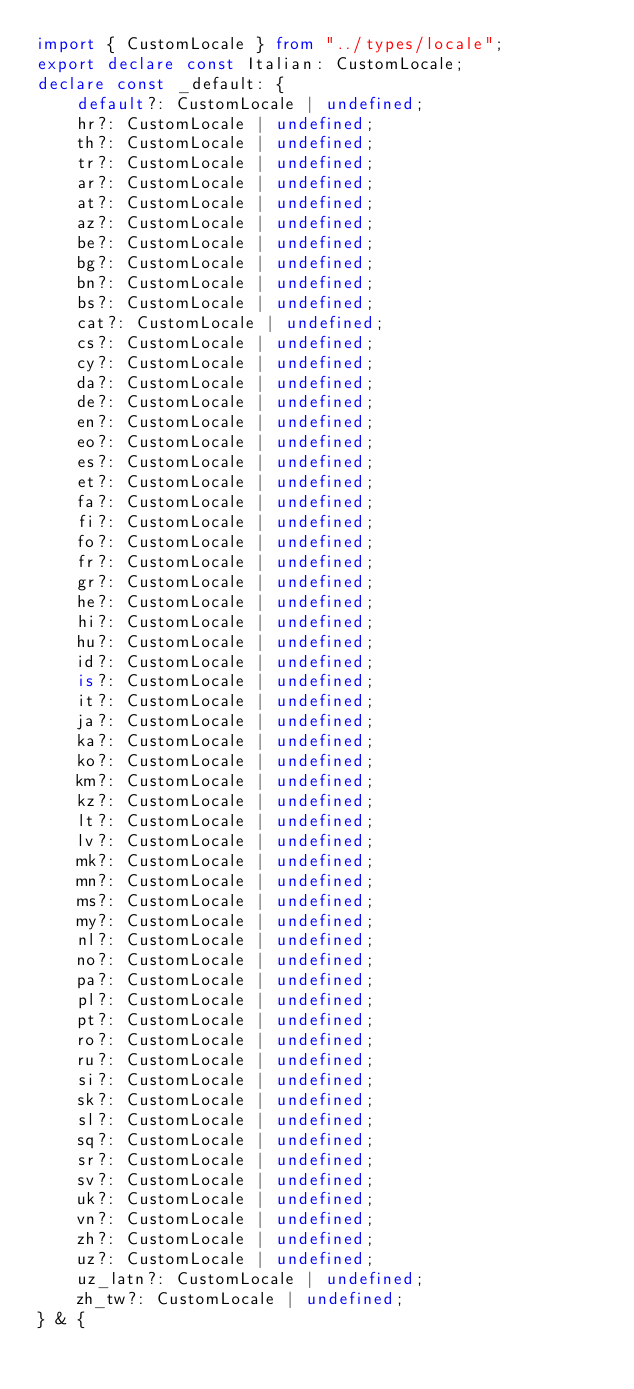Convert code to text. <code><loc_0><loc_0><loc_500><loc_500><_TypeScript_>import { CustomLocale } from "../types/locale";
export declare const Italian: CustomLocale;
declare const _default: {
    default?: CustomLocale | undefined;
    hr?: CustomLocale | undefined;
    th?: CustomLocale | undefined;
    tr?: CustomLocale | undefined;
    ar?: CustomLocale | undefined;
    at?: CustomLocale | undefined;
    az?: CustomLocale | undefined;
    be?: CustomLocale | undefined;
    bg?: CustomLocale | undefined;
    bn?: CustomLocale | undefined;
    bs?: CustomLocale | undefined;
    cat?: CustomLocale | undefined;
    cs?: CustomLocale | undefined;
    cy?: CustomLocale | undefined;
    da?: CustomLocale | undefined;
    de?: CustomLocale | undefined;
    en?: CustomLocale | undefined;
    eo?: CustomLocale | undefined;
    es?: CustomLocale | undefined;
    et?: CustomLocale | undefined;
    fa?: CustomLocale | undefined;
    fi?: CustomLocale | undefined;
    fo?: CustomLocale | undefined;
    fr?: CustomLocale | undefined;
    gr?: CustomLocale | undefined;
    he?: CustomLocale | undefined;
    hi?: CustomLocale | undefined;
    hu?: CustomLocale | undefined;
    id?: CustomLocale | undefined;
    is?: CustomLocale | undefined;
    it?: CustomLocale | undefined;
    ja?: CustomLocale | undefined;
    ka?: CustomLocale | undefined;
    ko?: CustomLocale | undefined;
    km?: CustomLocale | undefined;
    kz?: CustomLocale | undefined;
    lt?: CustomLocale | undefined;
    lv?: CustomLocale | undefined;
    mk?: CustomLocale | undefined;
    mn?: CustomLocale | undefined;
    ms?: CustomLocale | undefined;
    my?: CustomLocale | undefined;
    nl?: CustomLocale | undefined;
    no?: CustomLocale | undefined;
    pa?: CustomLocale | undefined;
    pl?: CustomLocale | undefined;
    pt?: CustomLocale | undefined;
    ro?: CustomLocale | undefined;
    ru?: CustomLocale | undefined;
    si?: CustomLocale | undefined;
    sk?: CustomLocale | undefined;
    sl?: CustomLocale | undefined;
    sq?: CustomLocale | undefined;
    sr?: CustomLocale | undefined;
    sv?: CustomLocale | undefined;
    uk?: CustomLocale | undefined;
    vn?: CustomLocale | undefined;
    zh?: CustomLocale | undefined;
    uz?: CustomLocale | undefined;
    uz_latn?: CustomLocale | undefined;
    zh_tw?: CustomLocale | undefined;
} & {</code> 